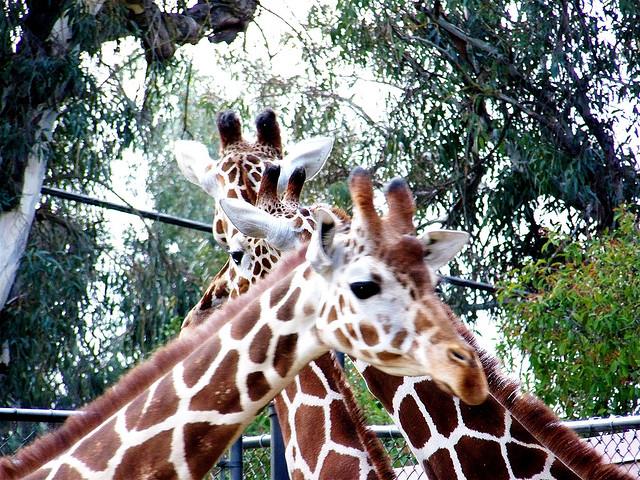Are the giraffes eating?
Short answer required. No. How many giraffes are there?
Concise answer only. 3. Are the giraffes in their natural habitat?
Be succinct. No. 